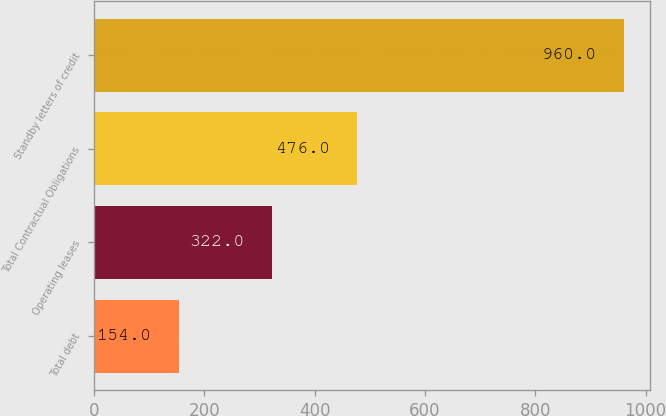<chart> <loc_0><loc_0><loc_500><loc_500><bar_chart><fcel>Total debt<fcel>Operating leases<fcel>Total Contractual Obligations<fcel>Standby letters of credit<nl><fcel>154<fcel>322<fcel>476<fcel>960<nl></chart> 